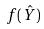<formula> <loc_0><loc_0><loc_500><loc_500>f ( \hat { Y } )</formula> 